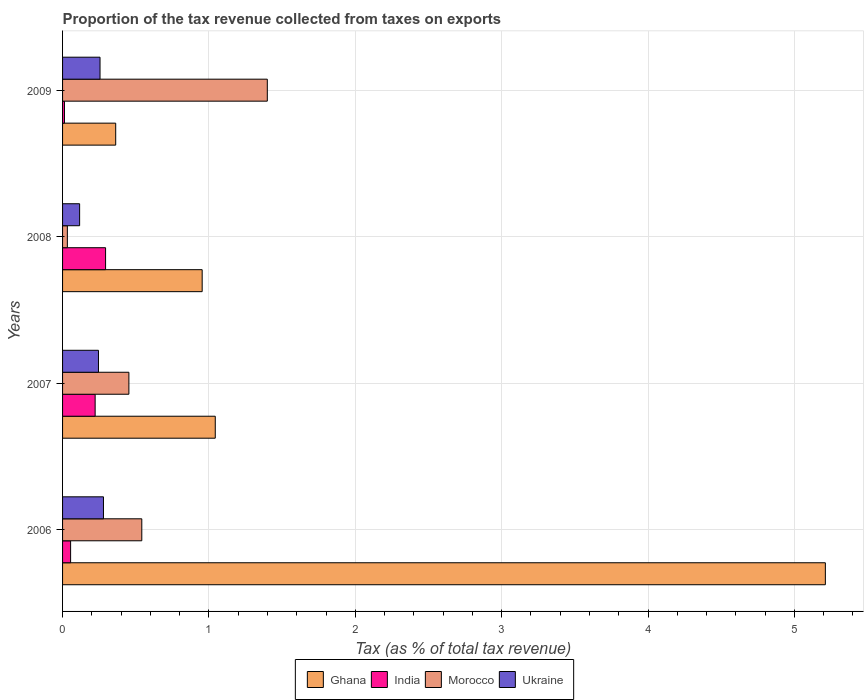How many groups of bars are there?
Provide a succinct answer. 4. Are the number of bars per tick equal to the number of legend labels?
Offer a terse response. Yes. Are the number of bars on each tick of the Y-axis equal?
Keep it short and to the point. Yes. How many bars are there on the 2nd tick from the bottom?
Give a very brief answer. 4. What is the label of the 1st group of bars from the top?
Give a very brief answer. 2009. What is the proportion of the tax revenue collected in Ukraine in 2006?
Your answer should be very brief. 0.28. Across all years, what is the maximum proportion of the tax revenue collected in Ghana?
Keep it short and to the point. 5.21. Across all years, what is the minimum proportion of the tax revenue collected in Morocco?
Offer a very short reply. 0.03. What is the total proportion of the tax revenue collected in India in the graph?
Ensure brevity in your answer.  0.58. What is the difference between the proportion of the tax revenue collected in India in 2006 and that in 2007?
Give a very brief answer. -0.17. What is the difference between the proportion of the tax revenue collected in Ukraine in 2008 and the proportion of the tax revenue collected in Ghana in 2007?
Give a very brief answer. -0.93. What is the average proportion of the tax revenue collected in Morocco per year?
Make the answer very short. 0.61. In the year 2009, what is the difference between the proportion of the tax revenue collected in Ukraine and proportion of the tax revenue collected in Morocco?
Make the answer very short. -1.14. What is the ratio of the proportion of the tax revenue collected in Ghana in 2006 to that in 2009?
Offer a terse response. 14.35. What is the difference between the highest and the second highest proportion of the tax revenue collected in Ghana?
Ensure brevity in your answer.  4.17. What is the difference between the highest and the lowest proportion of the tax revenue collected in Ghana?
Ensure brevity in your answer.  4.85. What does the 2nd bar from the bottom in 2007 represents?
Make the answer very short. India. Is it the case that in every year, the sum of the proportion of the tax revenue collected in Ghana and proportion of the tax revenue collected in India is greater than the proportion of the tax revenue collected in Ukraine?
Keep it short and to the point. Yes. How many years are there in the graph?
Provide a short and direct response. 4. Are the values on the major ticks of X-axis written in scientific E-notation?
Ensure brevity in your answer.  No. Does the graph contain any zero values?
Your answer should be very brief. No. What is the title of the graph?
Ensure brevity in your answer.  Proportion of the tax revenue collected from taxes on exports. What is the label or title of the X-axis?
Give a very brief answer. Tax (as % of total tax revenue). What is the label or title of the Y-axis?
Ensure brevity in your answer.  Years. What is the Tax (as % of total tax revenue) in Ghana in 2006?
Your answer should be very brief. 5.21. What is the Tax (as % of total tax revenue) in India in 2006?
Offer a very short reply. 0.05. What is the Tax (as % of total tax revenue) in Morocco in 2006?
Provide a short and direct response. 0.54. What is the Tax (as % of total tax revenue) of Ukraine in 2006?
Offer a very short reply. 0.28. What is the Tax (as % of total tax revenue) of Ghana in 2007?
Make the answer very short. 1.04. What is the Tax (as % of total tax revenue) of India in 2007?
Offer a very short reply. 0.22. What is the Tax (as % of total tax revenue) in Morocco in 2007?
Ensure brevity in your answer.  0.45. What is the Tax (as % of total tax revenue) of Ukraine in 2007?
Give a very brief answer. 0.25. What is the Tax (as % of total tax revenue) in Ghana in 2008?
Offer a very short reply. 0.95. What is the Tax (as % of total tax revenue) of India in 2008?
Your answer should be compact. 0.29. What is the Tax (as % of total tax revenue) of Morocco in 2008?
Provide a succinct answer. 0.03. What is the Tax (as % of total tax revenue) in Ukraine in 2008?
Make the answer very short. 0.12. What is the Tax (as % of total tax revenue) in Ghana in 2009?
Your answer should be compact. 0.36. What is the Tax (as % of total tax revenue) in India in 2009?
Provide a succinct answer. 0.01. What is the Tax (as % of total tax revenue) of Morocco in 2009?
Provide a short and direct response. 1.4. What is the Tax (as % of total tax revenue) in Ukraine in 2009?
Give a very brief answer. 0.26. Across all years, what is the maximum Tax (as % of total tax revenue) of Ghana?
Your response must be concise. 5.21. Across all years, what is the maximum Tax (as % of total tax revenue) in India?
Keep it short and to the point. 0.29. Across all years, what is the maximum Tax (as % of total tax revenue) in Morocco?
Make the answer very short. 1.4. Across all years, what is the maximum Tax (as % of total tax revenue) of Ukraine?
Offer a very short reply. 0.28. Across all years, what is the minimum Tax (as % of total tax revenue) of Ghana?
Provide a succinct answer. 0.36. Across all years, what is the minimum Tax (as % of total tax revenue) in India?
Your answer should be compact. 0.01. Across all years, what is the minimum Tax (as % of total tax revenue) in Morocco?
Make the answer very short. 0.03. Across all years, what is the minimum Tax (as % of total tax revenue) of Ukraine?
Your answer should be compact. 0.12. What is the total Tax (as % of total tax revenue) in Ghana in the graph?
Offer a very short reply. 7.57. What is the total Tax (as % of total tax revenue) in India in the graph?
Ensure brevity in your answer.  0.58. What is the total Tax (as % of total tax revenue) in Morocco in the graph?
Ensure brevity in your answer.  2.43. What is the total Tax (as % of total tax revenue) of Ukraine in the graph?
Your answer should be very brief. 0.9. What is the difference between the Tax (as % of total tax revenue) of Ghana in 2006 and that in 2007?
Your response must be concise. 4.17. What is the difference between the Tax (as % of total tax revenue) in India in 2006 and that in 2007?
Provide a short and direct response. -0.17. What is the difference between the Tax (as % of total tax revenue) in Morocco in 2006 and that in 2007?
Make the answer very short. 0.09. What is the difference between the Tax (as % of total tax revenue) of Ukraine in 2006 and that in 2007?
Offer a terse response. 0.03. What is the difference between the Tax (as % of total tax revenue) in Ghana in 2006 and that in 2008?
Keep it short and to the point. 4.26. What is the difference between the Tax (as % of total tax revenue) in India in 2006 and that in 2008?
Provide a short and direct response. -0.24. What is the difference between the Tax (as % of total tax revenue) in Morocco in 2006 and that in 2008?
Provide a succinct answer. 0.51. What is the difference between the Tax (as % of total tax revenue) of Ukraine in 2006 and that in 2008?
Provide a short and direct response. 0.16. What is the difference between the Tax (as % of total tax revenue) in Ghana in 2006 and that in 2009?
Provide a succinct answer. 4.85. What is the difference between the Tax (as % of total tax revenue) in India in 2006 and that in 2009?
Ensure brevity in your answer.  0.04. What is the difference between the Tax (as % of total tax revenue) of Morocco in 2006 and that in 2009?
Your answer should be compact. -0.86. What is the difference between the Tax (as % of total tax revenue) in Ukraine in 2006 and that in 2009?
Offer a terse response. 0.02. What is the difference between the Tax (as % of total tax revenue) of Ghana in 2007 and that in 2008?
Keep it short and to the point. 0.09. What is the difference between the Tax (as % of total tax revenue) of India in 2007 and that in 2008?
Offer a terse response. -0.07. What is the difference between the Tax (as % of total tax revenue) in Morocco in 2007 and that in 2008?
Your answer should be very brief. 0.42. What is the difference between the Tax (as % of total tax revenue) of Ukraine in 2007 and that in 2008?
Offer a terse response. 0.13. What is the difference between the Tax (as % of total tax revenue) of Ghana in 2007 and that in 2009?
Provide a short and direct response. 0.68. What is the difference between the Tax (as % of total tax revenue) in India in 2007 and that in 2009?
Make the answer very short. 0.21. What is the difference between the Tax (as % of total tax revenue) in Morocco in 2007 and that in 2009?
Your answer should be compact. -0.95. What is the difference between the Tax (as % of total tax revenue) in Ukraine in 2007 and that in 2009?
Provide a succinct answer. -0.01. What is the difference between the Tax (as % of total tax revenue) of Ghana in 2008 and that in 2009?
Offer a very short reply. 0.59. What is the difference between the Tax (as % of total tax revenue) in India in 2008 and that in 2009?
Your response must be concise. 0.28. What is the difference between the Tax (as % of total tax revenue) of Morocco in 2008 and that in 2009?
Make the answer very short. -1.37. What is the difference between the Tax (as % of total tax revenue) of Ukraine in 2008 and that in 2009?
Provide a succinct answer. -0.14. What is the difference between the Tax (as % of total tax revenue) of Ghana in 2006 and the Tax (as % of total tax revenue) of India in 2007?
Your answer should be very brief. 4.99. What is the difference between the Tax (as % of total tax revenue) of Ghana in 2006 and the Tax (as % of total tax revenue) of Morocco in 2007?
Provide a succinct answer. 4.76. What is the difference between the Tax (as % of total tax revenue) of Ghana in 2006 and the Tax (as % of total tax revenue) of Ukraine in 2007?
Provide a short and direct response. 4.97. What is the difference between the Tax (as % of total tax revenue) of India in 2006 and the Tax (as % of total tax revenue) of Morocco in 2007?
Offer a terse response. -0.4. What is the difference between the Tax (as % of total tax revenue) in India in 2006 and the Tax (as % of total tax revenue) in Ukraine in 2007?
Provide a short and direct response. -0.19. What is the difference between the Tax (as % of total tax revenue) in Morocco in 2006 and the Tax (as % of total tax revenue) in Ukraine in 2007?
Provide a short and direct response. 0.3. What is the difference between the Tax (as % of total tax revenue) of Ghana in 2006 and the Tax (as % of total tax revenue) of India in 2008?
Make the answer very short. 4.92. What is the difference between the Tax (as % of total tax revenue) of Ghana in 2006 and the Tax (as % of total tax revenue) of Morocco in 2008?
Provide a succinct answer. 5.18. What is the difference between the Tax (as % of total tax revenue) of Ghana in 2006 and the Tax (as % of total tax revenue) of Ukraine in 2008?
Offer a very short reply. 5.1. What is the difference between the Tax (as % of total tax revenue) in India in 2006 and the Tax (as % of total tax revenue) in Morocco in 2008?
Ensure brevity in your answer.  0.02. What is the difference between the Tax (as % of total tax revenue) of India in 2006 and the Tax (as % of total tax revenue) of Ukraine in 2008?
Your response must be concise. -0.06. What is the difference between the Tax (as % of total tax revenue) of Morocco in 2006 and the Tax (as % of total tax revenue) of Ukraine in 2008?
Keep it short and to the point. 0.42. What is the difference between the Tax (as % of total tax revenue) in Ghana in 2006 and the Tax (as % of total tax revenue) in India in 2009?
Your response must be concise. 5.2. What is the difference between the Tax (as % of total tax revenue) in Ghana in 2006 and the Tax (as % of total tax revenue) in Morocco in 2009?
Provide a short and direct response. 3.81. What is the difference between the Tax (as % of total tax revenue) in Ghana in 2006 and the Tax (as % of total tax revenue) in Ukraine in 2009?
Your response must be concise. 4.96. What is the difference between the Tax (as % of total tax revenue) of India in 2006 and the Tax (as % of total tax revenue) of Morocco in 2009?
Ensure brevity in your answer.  -1.34. What is the difference between the Tax (as % of total tax revenue) of India in 2006 and the Tax (as % of total tax revenue) of Ukraine in 2009?
Offer a terse response. -0.2. What is the difference between the Tax (as % of total tax revenue) of Morocco in 2006 and the Tax (as % of total tax revenue) of Ukraine in 2009?
Provide a short and direct response. 0.29. What is the difference between the Tax (as % of total tax revenue) in Ghana in 2007 and the Tax (as % of total tax revenue) in India in 2008?
Keep it short and to the point. 0.75. What is the difference between the Tax (as % of total tax revenue) of Ghana in 2007 and the Tax (as % of total tax revenue) of Morocco in 2008?
Your response must be concise. 1.01. What is the difference between the Tax (as % of total tax revenue) of Ghana in 2007 and the Tax (as % of total tax revenue) of Ukraine in 2008?
Make the answer very short. 0.93. What is the difference between the Tax (as % of total tax revenue) of India in 2007 and the Tax (as % of total tax revenue) of Morocco in 2008?
Provide a succinct answer. 0.19. What is the difference between the Tax (as % of total tax revenue) of India in 2007 and the Tax (as % of total tax revenue) of Ukraine in 2008?
Give a very brief answer. 0.11. What is the difference between the Tax (as % of total tax revenue) of Morocco in 2007 and the Tax (as % of total tax revenue) of Ukraine in 2008?
Your response must be concise. 0.34. What is the difference between the Tax (as % of total tax revenue) of Ghana in 2007 and the Tax (as % of total tax revenue) of India in 2009?
Offer a terse response. 1.03. What is the difference between the Tax (as % of total tax revenue) of Ghana in 2007 and the Tax (as % of total tax revenue) of Morocco in 2009?
Provide a succinct answer. -0.36. What is the difference between the Tax (as % of total tax revenue) of Ghana in 2007 and the Tax (as % of total tax revenue) of Ukraine in 2009?
Your answer should be very brief. 0.79. What is the difference between the Tax (as % of total tax revenue) in India in 2007 and the Tax (as % of total tax revenue) in Morocco in 2009?
Provide a succinct answer. -1.18. What is the difference between the Tax (as % of total tax revenue) in India in 2007 and the Tax (as % of total tax revenue) in Ukraine in 2009?
Your answer should be compact. -0.03. What is the difference between the Tax (as % of total tax revenue) of Morocco in 2007 and the Tax (as % of total tax revenue) of Ukraine in 2009?
Provide a succinct answer. 0.2. What is the difference between the Tax (as % of total tax revenue) in Ghana in 2008 and the Tax (as % of total tax revenue) in India in 2009?
Make the answer very short. 0.94. What is the difference between the Tax (as % of total tax revenue) in Ghana in 2008 and the Tax (as % of total tax revenue) in Morocco in 2009?
Your response must be concise. -0.45. What is the difference between the Tax (as % of total tax revenue) in Ghana in 2008 and the Tax (as % of total tax revenue) in Ukraine in 2009?
Your answer should be very brief. 0.7. What is the difference between the Tax (as % of total tax revenue) of India in 2008 and the Tax (as % of total tax revenue) of Morocco in 2009?
Your answer should be very brief. -1.1. What is the difference between the Tax (as % of total tax revenue) in India in 2008 and the Tax (as % of total tax revenue) in Ukraine in 2009?
Provide a short and direct response. 0.04. What is the difference between the Tax (as % of total tax revenue) in Morocco in 2008 and the Tax (as % of total tax revenue) in Ukraine in 2009?
Offer a terse response. -0.22. What is the average Tax (as % of total tax revenue) in Ghana per year?
Your answer should be compact. 1.89. What is the average Tax (as % of total tax revenue) of India per year?
Ensure brevity in your answer.  0.15. What is the average Tax (as % of total tax revenue) in Morocco per year?
Provide a succinct answer. 0.61. What is the average Tax (as % of total tax revenue) in Ukraine per year?
Give a very brief answer. 0.22. In the year 2006, what is the difference between the Tax (as % of total tax revenue) of Ghana and Tax (as % of total tax revenue) of India?
Ensure brevity in your answer.  5.16. In the year 2006, what is the difference between the Tax (as % of total tax revenue) of Ghana and Tax (as % of total tax revenue) of Morocco?
Your response must be concise. 4.67. In the year 2006, what is the difference between the Tax (as % of total tax revenue) of Ghana and Tax (as % of total tax revenue) of Ukraine?
Your answer should be compact. 4.93. In the year 2006, what is the difference between the Tax (as % of total tax revenue) in India and Tax (as % of total tax revenue) in Morocco?
Offer a terse response. -0.49. In the year 2006, what is the difference between the Tax (as % of total tax revenue) of India and Tax (as % of total tax revenue) of Ukraine?
Ensure brevity in your answer.  -0.22. In the year 2006, what is the difference between the Tax (as % of total tax revenue) in Morocco and Tax (as % of total tax revenue) in Ukraine?
Provide a short and direct response. 0.26. In the year 2007, what is the difference between the Tax (as % of total tax revenue) of Ghana and Tax (as % of total tax revenue) of India?
Provide a succinct answer. 0.82. In the year 2007, what is the difference between the Tax (as % of total tax revenue) in Ghana and Tax (as % of total tax revenue) in Morocco?
Offer a very short reply. 0.59. In the year 2007, what is the difference between the Tax (as % of total tax revenue) in Ghana and Tax (as % of total tax revenue) in Ukraine?
Your answer should be very brief. 0.8. In the year 2007, what is the difference between the Tax (as % of total tax revenue) of India and Tax (as % of total tax revenue) of Morocco?
Provide a short and direct response. -0.23. In the year 2007, what is the difference between the Tax (as % of total tax revenue) in India and Tax (as % of total tax revenue) in Ukraine?
Your answer should be very brief. -0.02. In the year 2007, what is the difference between the Tax (as % of total tax revenue) in Morocco and Tax (as % of total tax revenue) in Ukraine?
Give a very brief answer. 0.21. In the year 2008, what is the difference between the Tax (as % of total tax revenue) in Ghana and Tax (as % of total tax revenue) in India?
Provide a succinct answer. 0.66. In the year 2008, what is the difference between the Tax (as % of total tax revenue) of Ghana and Tax (as % of total tax revenue) of Morocco?
Give a very brief answer. 0.92. In the year 2008, what is the difference between the Tax (as % of total tax revenue) of Ghana and Tax (as % of total tax revenue) of Ukraine?
Offer a terse response. 0.84. In the year 2008, what is the difference between the Tax (as % of total tax revenue) of India and Tax (as % of total tax revenue) of Morocco?
Give a very brief answer. 0.26. In the year 2008, what is the difference between the Tax (as % of total tax revenue) in India and Tax (as % of total tax revenue) in Ukraine?
Keep it short and to the point. 0.18. In the year 2008, what is the difference between the Tax (as % of total tax revenue) of Morocco and Tax (as % of total tax revenue) of Ukraine?
Ensure brevity in your answer.  -0.08. In the year 2009, what is the difference between the Tax (as % of total tax revenue) in Ghana and Tax (as % of total tax revenue) in India?
Provide a succinct answer. 0.35. In the year 2009, what is the difference between the Tax (as % of total tax revenue) in Ghana and Tax (as % of total tax revenue) in Morocco?
Offer a very short reply. -1.04. In the year 2009, what is the difference between the Tax (as % of total tax revenue) in Ghana and Tax (as % of total tax revenue) in Ukraine?
Your response must be concise. 0.11. In the year 2009, what is the difference between the Tax (as % of total tax revenue) of India and Tax (as % of total tax revenue) of Morocco?
Provide a short and direct response. -1.39. In the year 2009, what is the difference between the Tax (as % of total tax revenue) in India and Tax (as % of total tax revenue) in Ukraine?
Your answer should be compact. -0.24. In the year 2009, what is the difference between the Tax (as % of total tax revenue) of Morocco and Tax (as % of total tax revenue) of Ukraine?
Provide a succinct answer. 1.14. What is the ratio of the Tax (as % of total tax revenue) of Ghana in 2006 to that in 2007?
Provide a short and direct response. 5. What is the ratio of the Tax (as % of total tax revenue) in India in 2006 to that in 2007?
Your answer should be very brief. 0.25. What is the ratio of the Tax (as % of total tax revenue) of Morocco in 2006 to that in 2007?
Ensure brevity in your answer.  1.19. What is the ratio of the Tax (as % of total tax revenue) of Ukraine in 2006 to that in 2007?
Offer a very short reply. 1.14. What is the ratio of the Tax (as % of total tax revenue) of Ghana in 2006 to that in 2008?
Keep it short and to the point. 5.46. What is the ratio of the Tax (as % of total tax revenue) in India in 2006 to that in 2008?
Your answer should be compact. 0.19. What is the ratio of the Tax (as % of total tax revenue) in Morocco in 2006 to that in 2008?
Provide a short and direct response. 16.55. What is the ratio of the Tax (as % of total tax revenue) in Ukraine in 2006 to that in 2008?
Provide a short and direct response. 2.4. What is the ratio of the Tax (as % of total tax revenue) in Ghana in 2006 to that in 2009?
Your answer should be very brief. 14.35. What is the ratio of the Tax (as % of total tax revenue) of India in 2006 to that in 2009?
Provide a succinct answer. 4.23. What is the ratio of the Tax (as % of total tax revenue) of Morocco in 2006 to that in 2009?
Your answer should be compact. 0.39. What is the ratio of the Tax (as % of total tax revenue) in Ukraine in 2006 to that in 2009?
Ensure brevity in your answer.  1.09. What is the ratio of the Tax (as % of total tax revenue) of Ghana in 2007 to that in 2008?
Your answer should be compact. 1.09. What is the ratio of the Tax (as % of total tax revenue) of India in 2007 to that in 2008?
Keep it short and to the point. 0.76. What is the ratio of the Tax (as % of total tax revenue) in Morocco in 2007 to that in 2008?
Your answer should be very brief. 13.86. What is the ratio of the Tax (as % of total tax revenue) in Ukraine in 2007 to that in 2008?
Your answer should be compact. 2.1. What is the ratio of the Tax (as % of total tax revenue) in Ghana in 2007 to that in 2009?
Give a very brief answer. 2.87. What is the ratio of the Tax (as % of total tax revenue) in India in 2007 to that in 2009?
Provide a short and direct response. 17.16. What is the ratio of the Tax (as % of total tax revenue) in Morocco in 2007 to that in 2009?
Keep it short and to the point. 0.32. What is the ratio of the Tax (as % of total tax revenue) in Ghana in 2008 to that in 2009?
Your answer should be very brief. 2.63. What is the ratio of the Tax (as % of total tax revenue) in India in 2008 to that in 2009?
Keep it short and to the point. 22.66. What is the ratio of the Tax (as % of total tax revenue) of Morocco in 2008 to that in 2009?
Keep it short and to the point. 0.02. What is the ratio of the Tax (as % of total tax revenue) in Ukraine in 2008 to that in 2009?
Your answer should be compact. 0.46. What is the difference between the highest and the second highest Tax (as % of total tax revenue) in Ghana?
Ensure brevity in your answer.  4.17. What is the difference between the highest and the second highest Tax (as % of total tax revenue) of India?
Provide a short and direct response. 0.07. What is the difference between the highest and the second highest Tax (as % of total tax revenue) of Morocco?
Your answer should be compact. 0.86. What is the difference between the highest and the second highest Tax (as % of total tax revenue) in Ukraine?
Provide a succinct answer. 0.02. What is the difference between the highest and the lowest Tax (as % of total tax revenue) of Ghana?
Give a very brief answer. 4.85. What is the difference between the highest and the lowest Tax (as % of total tax revenue) in India?
Your answer should be compact. 0.28. What is the difference between the highest and the lowest Tax (as % of total tax revenue) of Morocco?
Keep it short and to the point. 1.37. What is the difference between the highest and the lowest Tax (as % of total tax revenue) of Ukraine?
Provide a short and direct response. 0.16. 